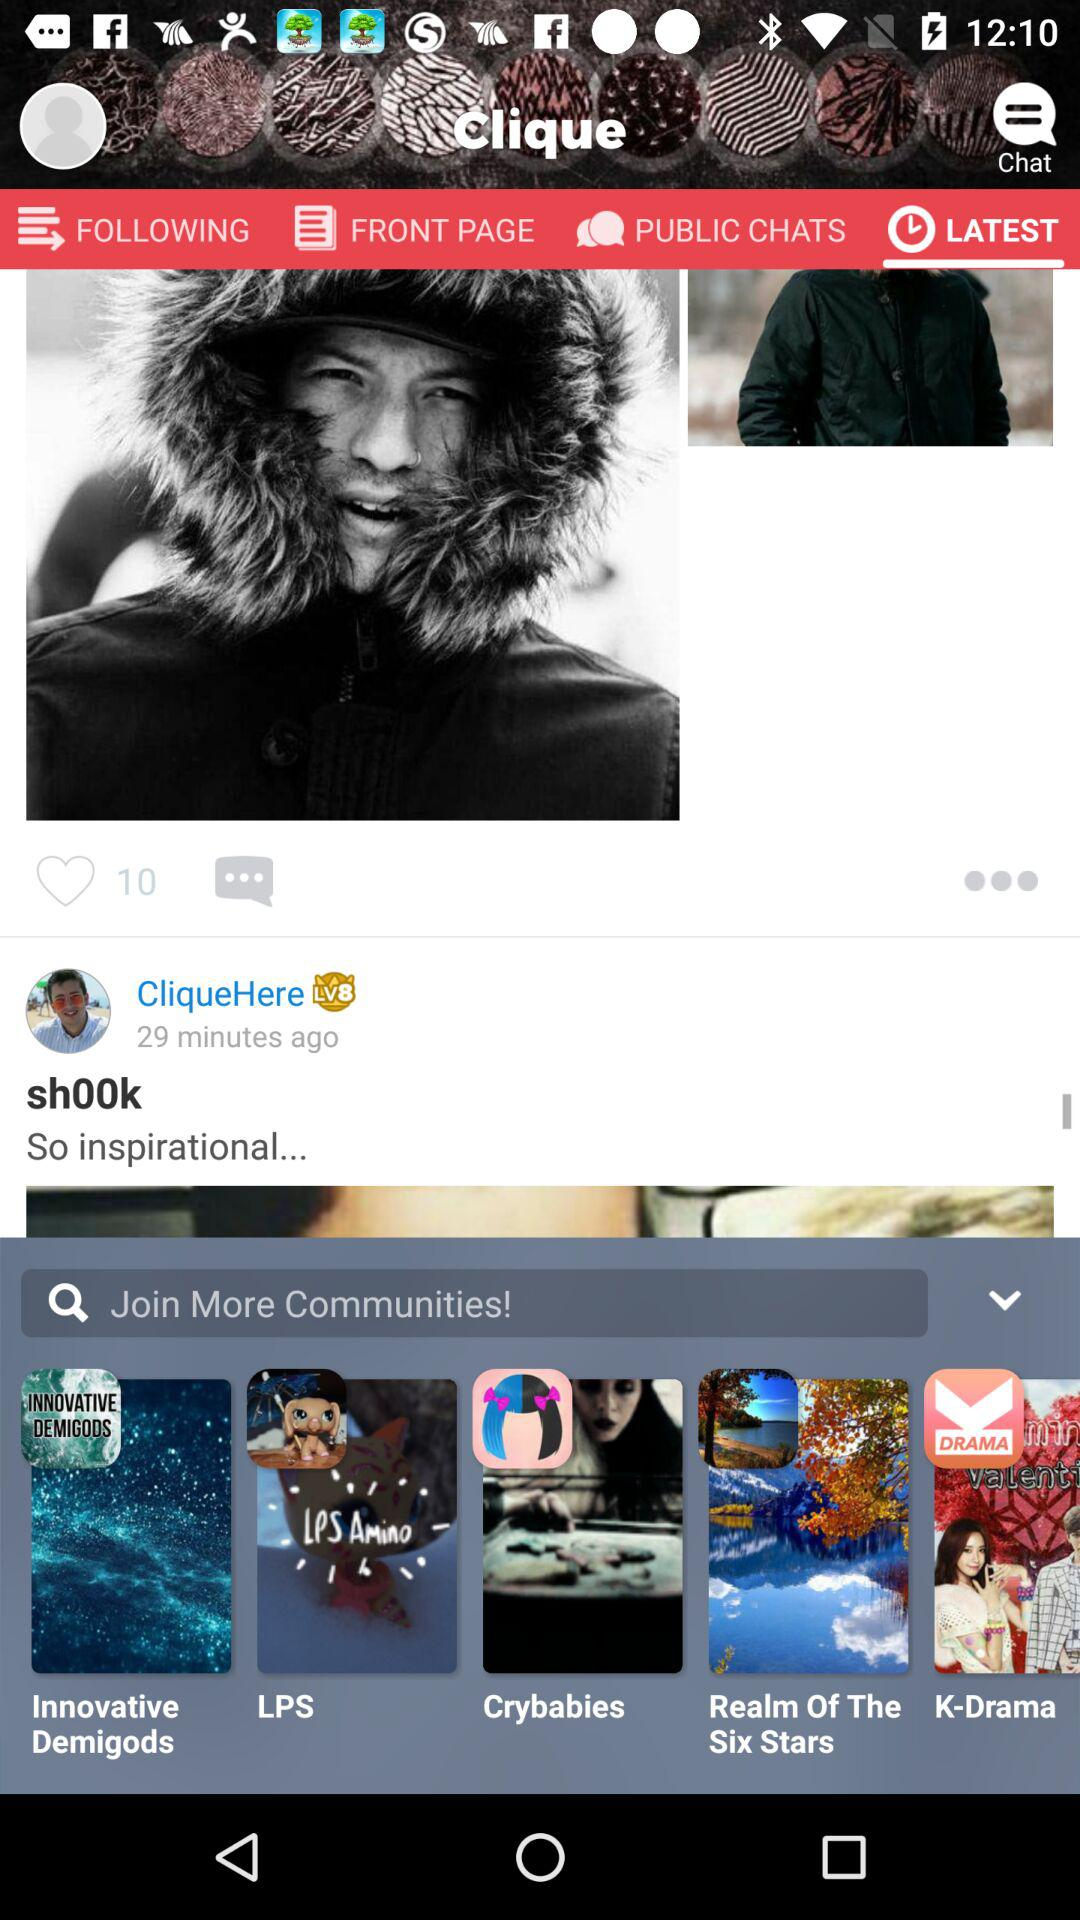What is the application name? The application name is "Clique". 